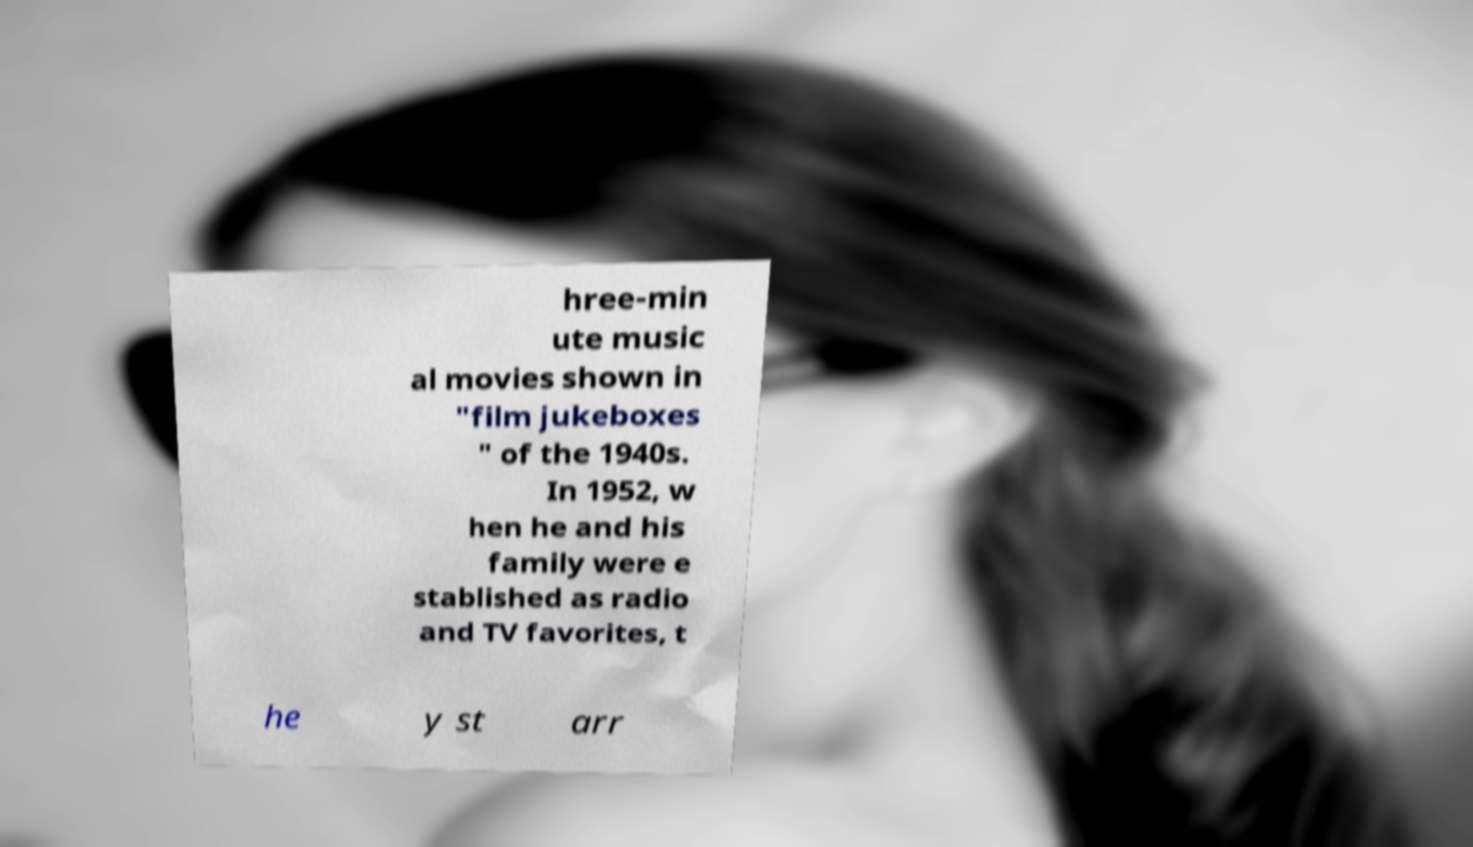Can you accurately transcribe the text from the provided image for me? hree-min ute music al movies shown in "film jukeboxes " of the 1940s. In 1952, w hen he and his family were e stablished as radio and TV favorites, t he y st arr 